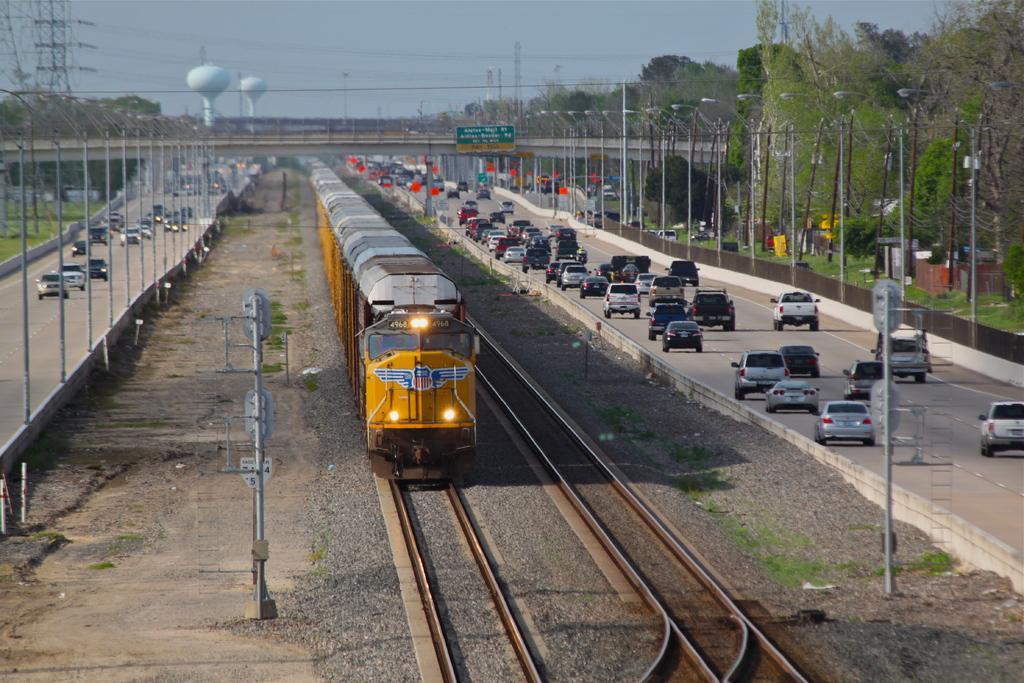Describe this image in one or two sentences. This picture is clicked outside. In the center we can see a yellow color train running on the railway track and we can see the gravels, poles, railway track and on both the sides we can see the group of vehicles running on the road. In the background we can see the sky, trees, bridge, poles, grass and metal rods and many other objects and we can see the text on the board. 